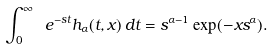<formula> <loc_0><loc_0><loc_500><loc_500>\int _ { 0 } ^ { \infty } \ e ^ { - s t } h _ { \alpha } ( t , x ) \, d t = s ^ { \alpha - 1 } \exp ( - x s ^ { \alpha } ) .</formula> 